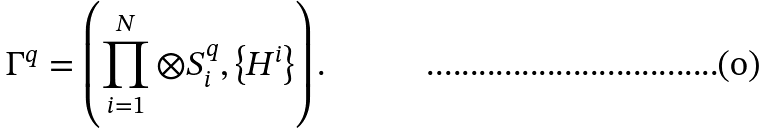Convert formula to latex. <formula><loc_0><loc_0><loc_500><loc_500>\Gamma ^ { q } = \left ( \prod _ { i = 1 } ^ { N } \otimes S ^ { q } _ { i } , \left \{ H ^ { i } \right \} \right ) .</formula> 